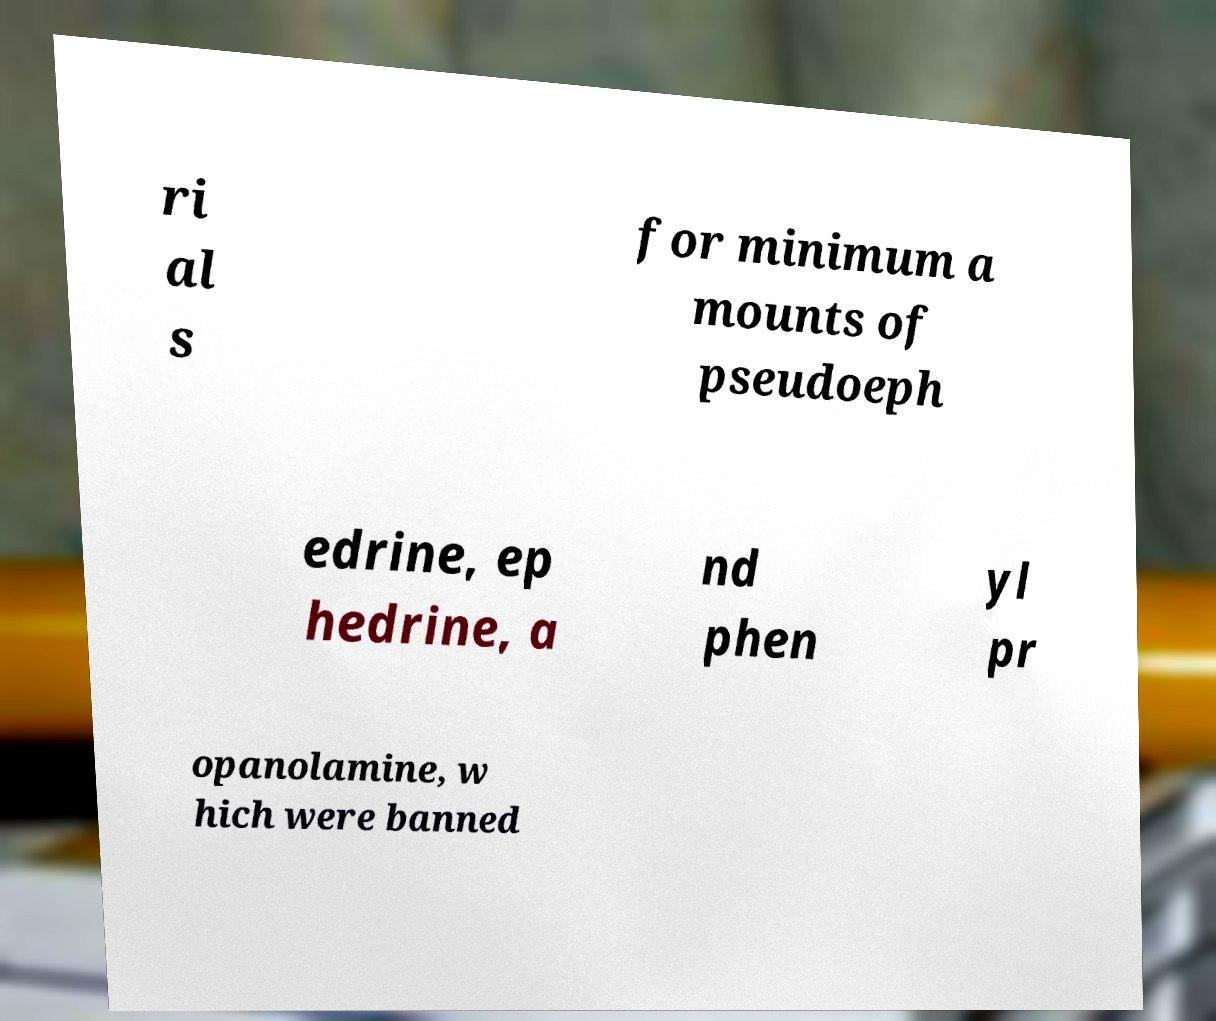There's text embedded in this image that I need extracted. Can you transcribe it verbatim? ri al s for minimum a mounts of pseudoeph edrine, ep hedrine, a nd phen yl pr opanolamine, w hich were banned 